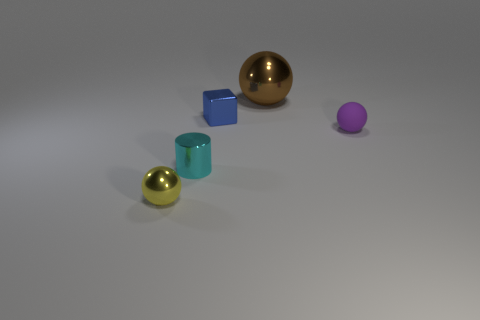Add 4 purple matte things. How many objects exist? 9 Subtract all purple spheres. How many spheres are left? 2 Subtract all small purple matte balls. How many balls are left? 2 Subtract all blocks. How many objects are left? 4 Subtract 1 brown balls. How many objects are left? 4 Subtract 3 balls. How many balls are left? 0 Subtract all purple spheres. Subtract all green cubes. How many spheres are left? 2 Subtract all blue balls. How many cyan blocks are left? 0 Subtract all big brown metal spheres. Subtract all metallic balls. How many objects are left? 2 Add 4 small purple things. How many small purple things are left? 5 